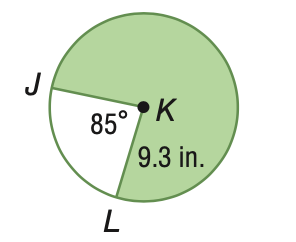Answer the mathemtical geometry problem and directly provide the correct option letter.
Question: Find the area of the shaded sector. Round to the nearest tenth.
Choices: A: 44.6 B: 64.2 C: 103.8 D: 207.6 D 